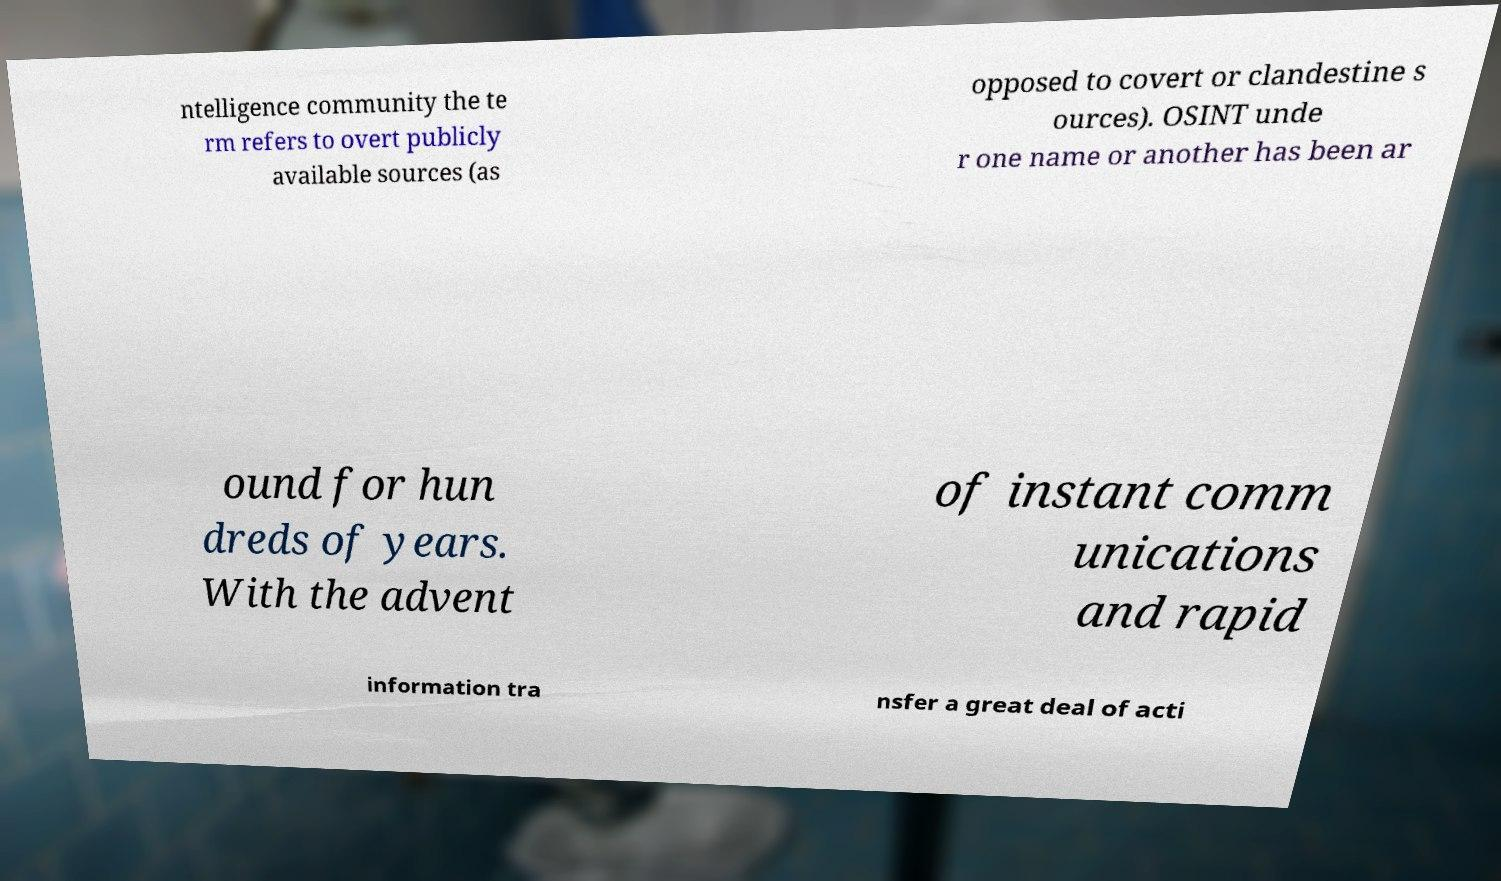Can you accurately transcribe the text from the provided image for me? ntelligence community the te rm refers to overt publicly available sources (as opposed to covert or clandestine s ources). OSINT unde r one name or another has been ar ound for hun dreds of years. With the advent of instant comm unications and rapid information tra nsfer a great deal of acti 